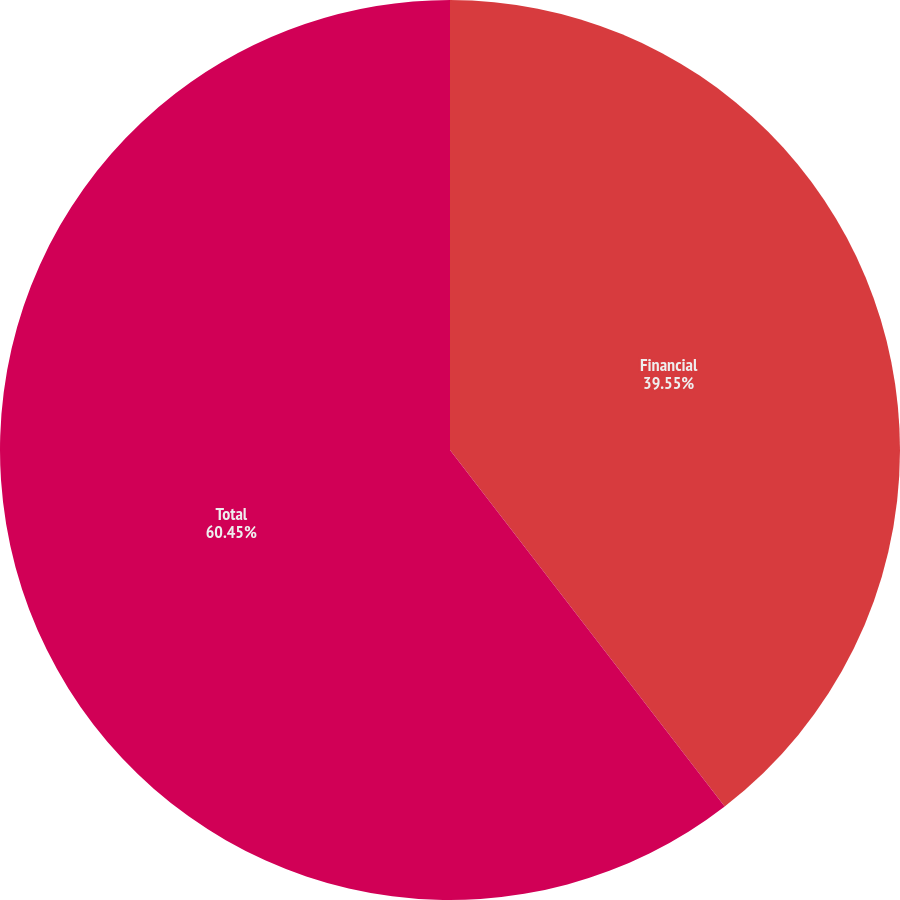<chart> <loc_0><loc_0><loc_500><loc_500><pie_chart><fcel>Financial<fcel>Total<nl><fcel>39.55%<fcel>60.45%<nl></chart> 